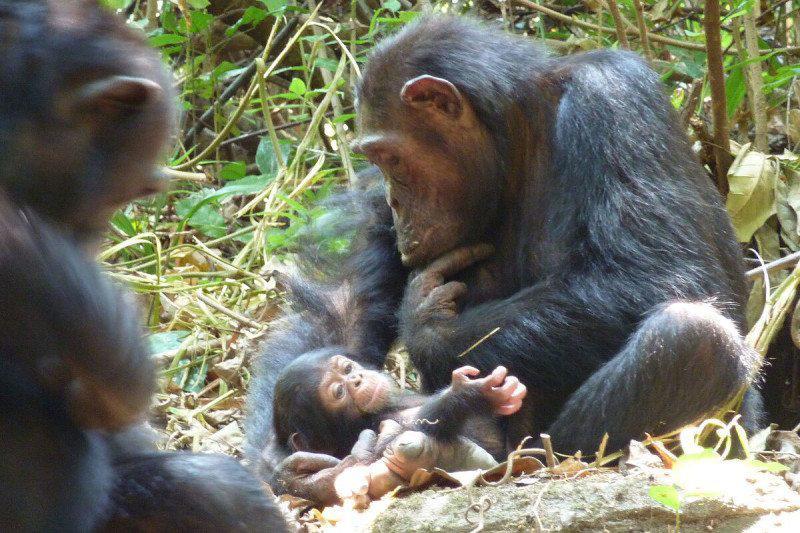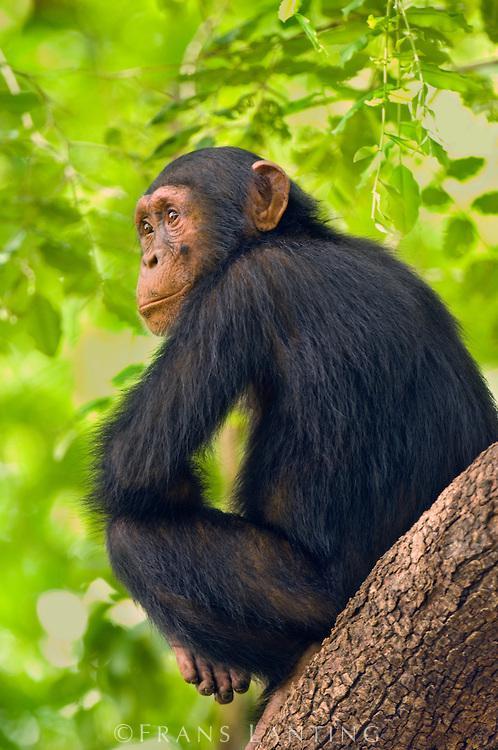The first image is the image on the left, the second image is the image on the right. For the images shown, is this caption "The image on the right features only one chimp." true? Answer yes or no. Yes. 